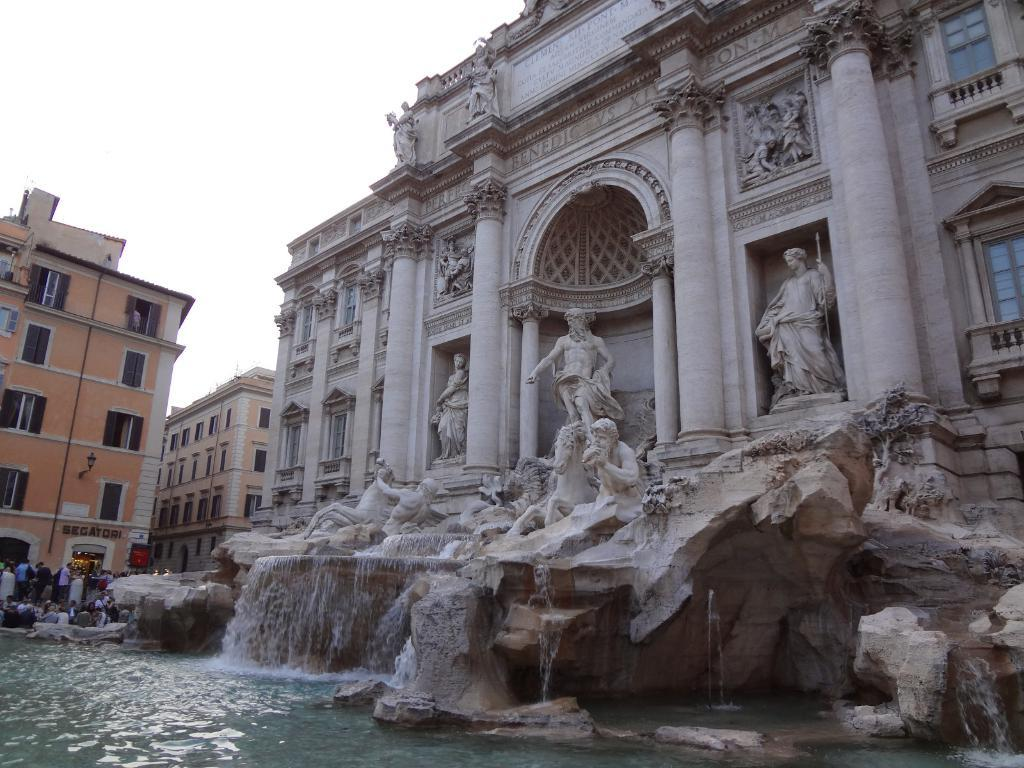What type of structures are present in the image? There are buildings in the image. What can be seen in front of the buildings? There are sculptures in front of the buildings. What natural element is visible in the image? There is water visible in the image. What feature do the buildings have? The buildings have windows. Who or what else can be seen in the image? There are people in the image. What type of tax is being discussed by the people in the image? There is no indication in the image that the people are discussing any type of tax. 